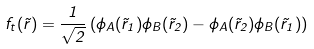<formula> <loc_0><loc_0><loc_500><loc_500>f _ { t } ( \vec { r } ) = \frac { 1 } { \sqrt { 2 } } \left ( \phi _ { A } ( \vec { r } _ { 1 } ) \phi _ { B } ( \vec { r } _ { 2 } ) - \phi _ { A } ( \vec { r } _ { 2 } ) \phi _ { B } ( \vec { r } _ { 1 } ) \right )</formula> 